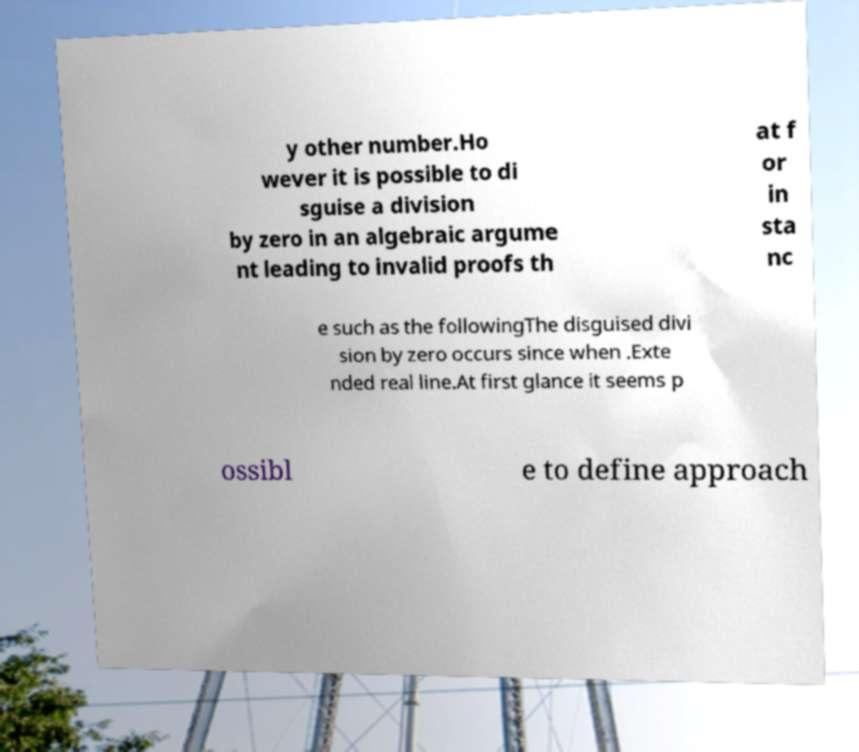Please identify and transcribe the text found in this image. y other number.Ho wever it is possible to di sguise a division by zero in an algebraic argume nt leading to invalid proofs th at f or in sta nc e such as the followingThe disguised divi sion by zero occurs since when .Exte nded real line.At first glance it seems p ossibl e to define approach 